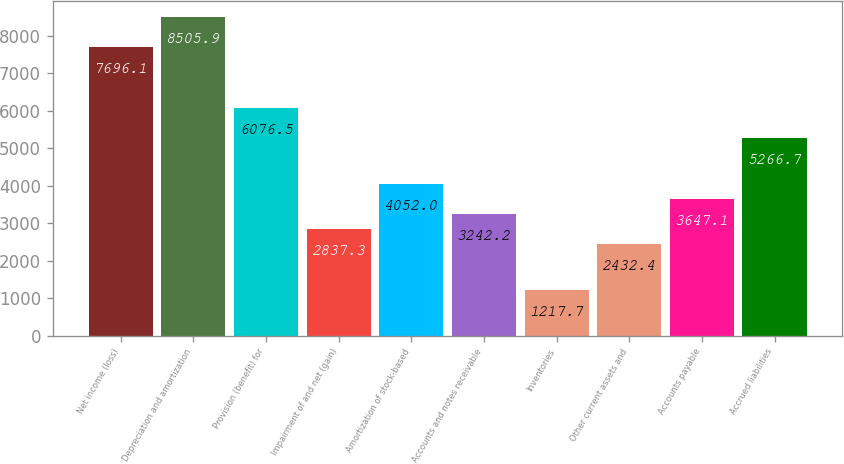<chart> <loc_0><loc_0><loc_500><loc_500><bar_chart><fcel>Net income (loss)<fcel>Depreciation and amortization<fcel>Provision (benefit) for<fcel>Impairment of and net (gain)<fcel>Amortization of stock-based<fcel>Accounts and notes receivable<fcel>Inventories<fcel>Other current assets and<fcel>Accounts payable<fcel>Accrued liabilities<nl><fcel>7696.1<fcel>8505.9<fcel>6076.5<fcel>2837.3<fcel>4052<fcel>3242.2<fcel>1217.7<fcel>2432.4<fcel>3647.1<fcel>5266.7<nl></chart> 